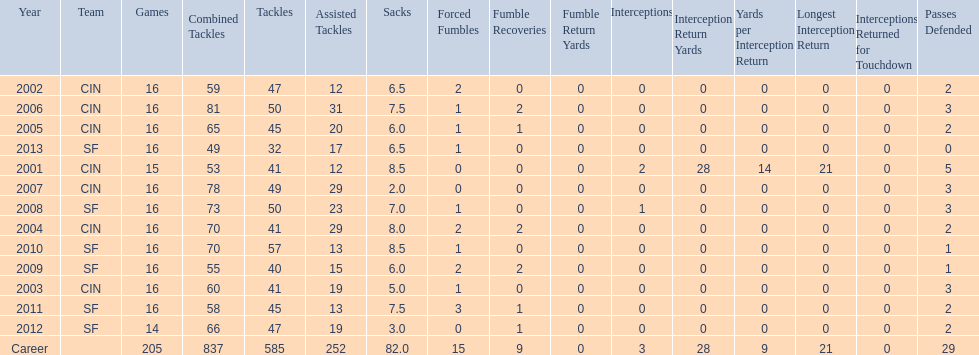What was the total number of fumble recoveries for this player in the year 2004? 2. 